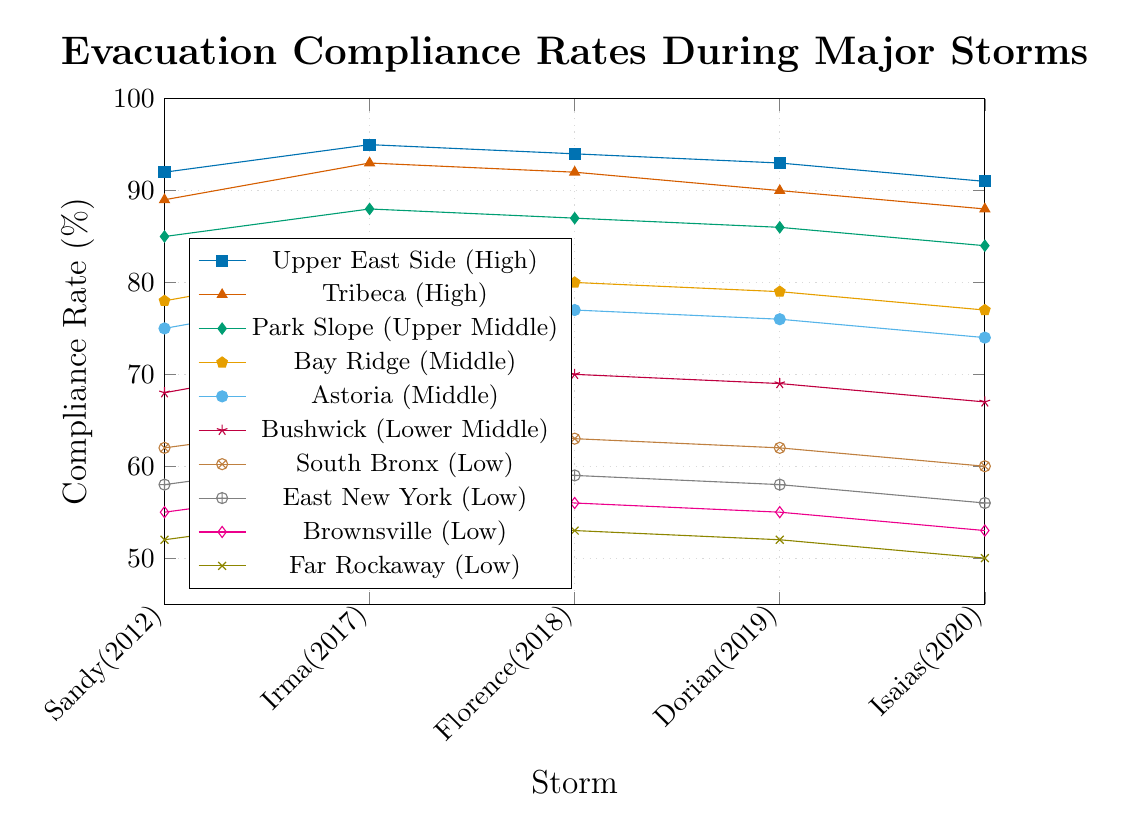Which neighborhood consistently has the highest evacuation compliance rate across all storms? The figure shows evacuation compliance rates for multiple neighborhoods across several storms, and we need to identify which neighborhood consistently has the highest rates. Upper East Side and Tribeca have high rates, but the Upper East Side has the highest in all storms.
Answer: Upper East Side How does the evacuation compliance in Upper East Side change from Hurricane Sandy to Hurricane Isaias? Look at the data points for Upper East Side across the storms from Sandy (92%) to Isaias (91%). Calculate the change: 91% - 92% = -1%.
Answer: Decreased by 1% Which storm shows the greatest difference in evacuation compliance between the Upper East Side and Far Rockaway? Compare the differences in compliance rates for Upper East Side and Far Rockaway for each storm. The differences are: Sandy (40%), Irma (40%), Florence (41%), Dorian (41%), Isaias (41%). The highest difference is for Florence, Dorian, and Isaias at 41%.
Answer: Florence, Dorian, and Isaias What is the average evacuation compliance rate for low-income neighborhoods during Hurricane Irma? Identify the low-income neighborhoods: South Bronx, East New York, Brownsville, Far Rockaway. Their rates for Irma are 65%, 61%, 58%, 55%. Calculate the average: (65 + 61 + 58 + 55) / 4 = 59.75%.
Answer: 59.75% Which neighborhood has the most significant decrease in compliance rate from Hurricane Sandy to Hurricane Isaias? Calculate the difference in compliance rates between Sandy and Isaias for each neighborhood. The differences are: Upper East Side (-1%), Tribeca (-1%), Park Slope (-1%), Bay Ridge (-1%), Astoria (-1%), Bushwick (-1%), South Bronx (-2%), East New York (-2%), Brownsville (-2%), Far Rockaway (-2%). Several neighborhoods have the same maximum decrease of 2%.
Answer: South Bronx, East New York, Brownsville, Far Rockaway Is there a trend in compliance rates for middle-income neighborhoods over the storms? Identify middle-income neighborhoods (Bay Ridge, Astoria) and observe their compliance rates across the storms. Both neighborhoods show a gradual decrease: Bay Ridge (78%, 82%, 80%, 79%, 77%) and Astoria (75%, 79%, 77%, 76%, 74%).
Answer: Gradual decrease How does the compliance rate for Bushwick compare to South Bronx during Hurricane Florence? Look at the compliance rates for Bushwick (70%) and South Bronx (63%) during Florence and compare them. Bushwick has a higher rate.
Answer: Bushwick has a higher rate by 7% What is the total evacuation compliance rate for Park Slope across all storms? Sum the rates for Park Slope across all storms: 85 + 88 + 87 + 86 + 84 = 430.
Answer: 430% Which neighborhood shows the most improvement in compliance rate from Hurricane Sandy to Hurricane Irma? Calculate the difference in compliance rates between Sandy and Irma for each neighborhood. The differences are: Upper East Side (+3%), Tribeca (+4%), Park Slope (+3%), Bay Ridge (+4%), Astoria (+4%), Bushwick (+4%), South Bronx (+3%), East New York (+3%), Brownsville (+3%), Far Rockaway (+3%). Several neighborhoods have the same maximum increase of 4%.
Answer: Tribeca, Bay Ridge, Astoria, Bushwick What is the range of evacuation compliance rates for Hurricane Dorian? Identify the highest and lowest rates for Dorian; highest is Upper East Side (93%) and lowest is Far Rockaway (52%). Calculate the range: 93% - 52% = 41%.
Answer: 41% 